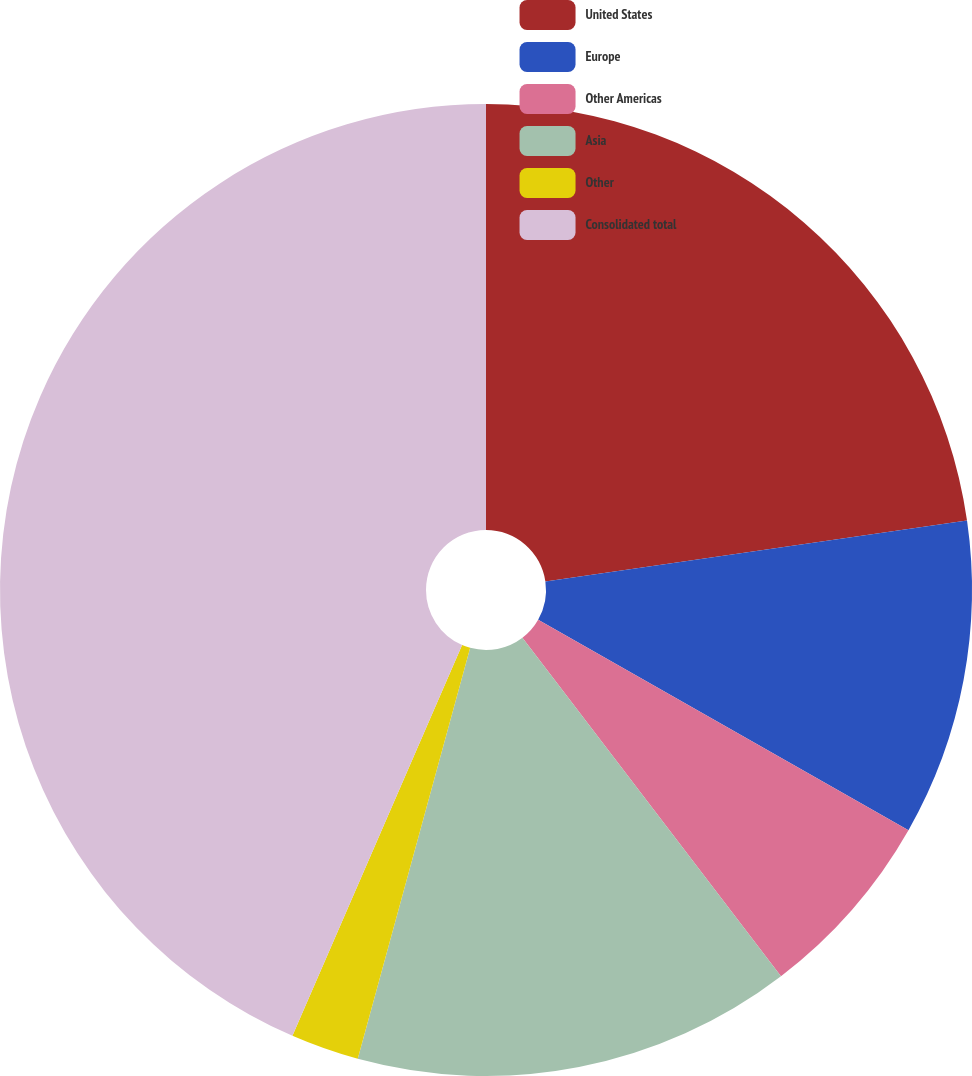Convert chart. <chart><loc_0><loc_0><loc_500><loc_500><pie_chart><fcel>United States<fcel>Europe<fcel>Other Americas<fcel>Asia<fcel>Other<fcel>Consolidated total<nl><fcel>22.72%<fcel>10.51%<fcel>6.39%<fcel>14.63%<fcel>2.27%<fcel>43.48%<nl></chart> 